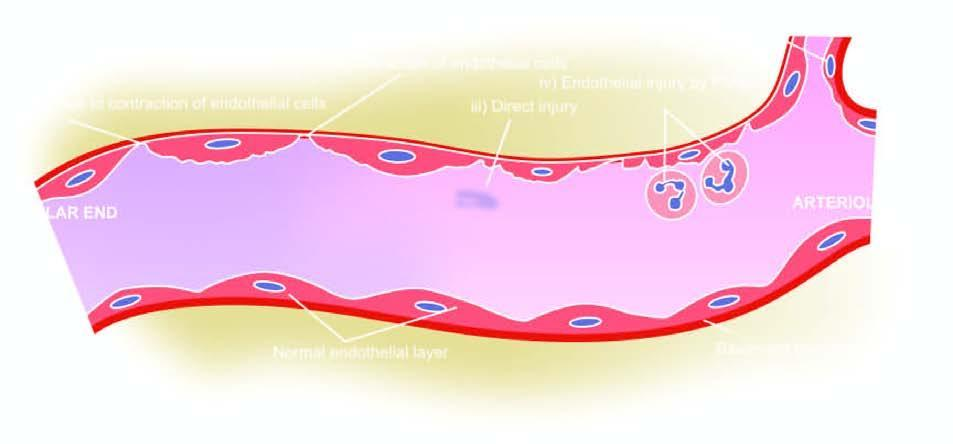how many numbers do the serial numbers in the figure correspond to?
Answer the question using a single word or phrase. Five 